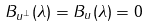Convert formula to latex. <formula><loc_0><loc_0><loc_500><loc_500>B _ { u ^ { \perp } } ( \lambda ) = B _ { u } ( \lambda ) = 0</formula> 